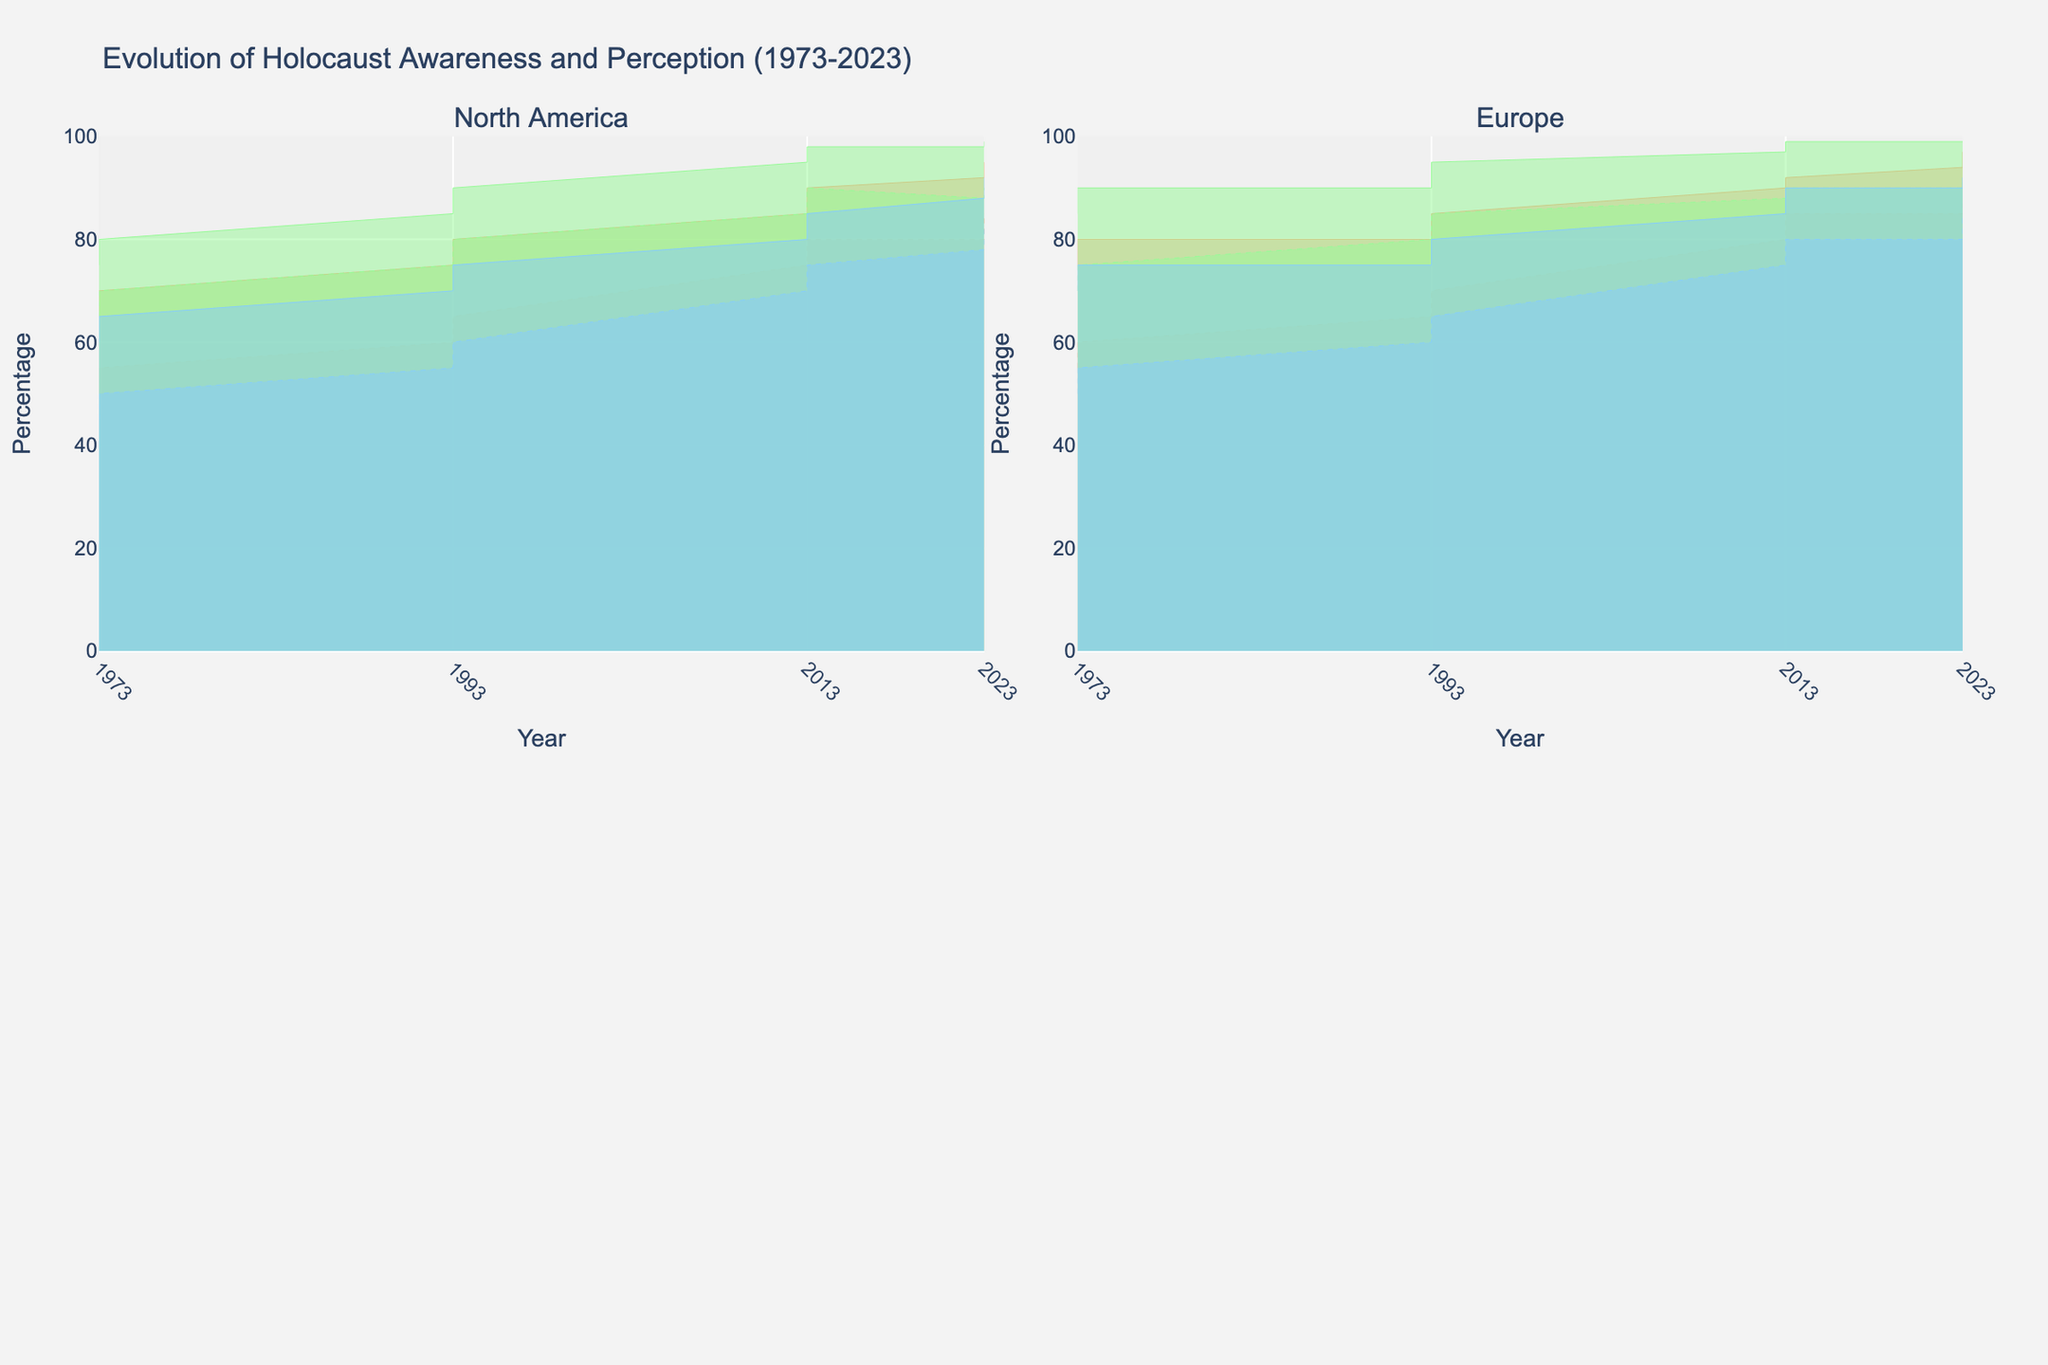What is the title of the chart? The title is typically located at the top of the chart. In this case, it reads "Evolution of Holocaust Awareness and Perception (1973-2023)."
Answer: Evolution of Holocaust Awareness and Perception (1973-2023) Which age group shows the highest awareness percentage in Europe in 2023? Observe the maximum awareness percentage for different age groups in the Europe subplot for the year 2023. The 31-50 age group reaches 99%.
Answer: 31-50 How did the perception of the Holocaust change for males aged 18-30 in North America from 1973 to 2023? Compare the perception percentages for males aged 18-30 in North America subplot from 1973 and 2023. In 1973, it was 50%, and in 2023, it was 80%. The increase is 80% - 50% = 30%.
Answer: Increased by 30% Which region shows the least increase in Holocaust awareness among the 51+ age group between 1973 and 2023? Compare the change in awareness percentage for the 51+ age group in both North America and Europe between 1973 and 2023. North America increased from 60% to 88%, while Europe increased from 70% to 90%. North America saw a smaller increase by 28% versus Europe's 20%.
Answer: North America Between North America and Europe, which region has a higher perception percentage for females aged 31-50 in 2013? Look at the perception percentage for females aged 31-50 in the respective subplots for the year 2013. In North America, it is 90%, while in Europe it is also 90%. Thus both regions have the same perception percentage.
Answer: Both are equal What's the average awareness percentage for females aged 31-50 in Europe over the years 1973, 1993, 2013, and 2023? Sum the awareness percentages for females aged 31-50 in Europe for each year and divide by the number of data points. The values are 90%, 95%, 99%, and 99%. (90 + 95 + 99 + 99)/4 = 95.75%.
Answer: 95.75% In which year did all the age groups in North America have at least an 80% awareness percentage? Review the awareness percentages for all age groups in North America for each year. In 2023, all age groups (18-30, 31-50, and 51+) had awareness percentages of at least 80%, with values 92%, 98%, and 88%, respectively.
Answer: 2023 Who had a higher perception in Europe in 1983, males aged 18-30 or males aged 51+? Locate the perception percentages for both groups in the Europe subplot for 1983. For males aged 18-30, it's 55%, and for males aged 51+, it's 50%. Thus, males aged 18-30 had a higher perception.
Answer: Males aged 18-30 What is the trend of Holocaust awareness for females aged 18-30 in North America from 1973 to 2023? Observe the trend lines for females aged 18-30 in North America in the corresponding subplot. The awareness percentage steadily increases from 70% in 1973 to 95% in 2023.
Answer: It increased What is the difference in the perception percentage between females aged 31-50 and males aged 31-50 in Europe in 2023? Check the perception percentages for both genders aged 31-50 in Europe subplot for 2023. For females, it is 91%, and for males, it is 90%. The difference is 91% - 90% = 1%.
Answer: 1% 